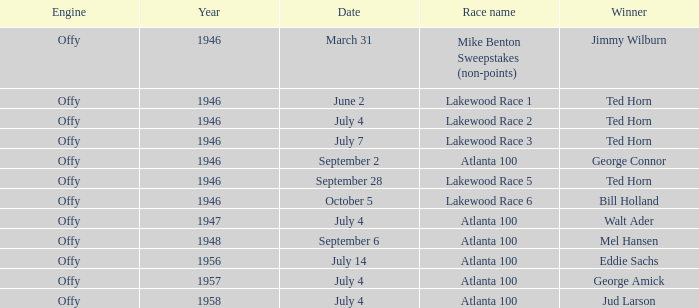Which race did Bill Holland win in 1946? Lakewood Race 6. 